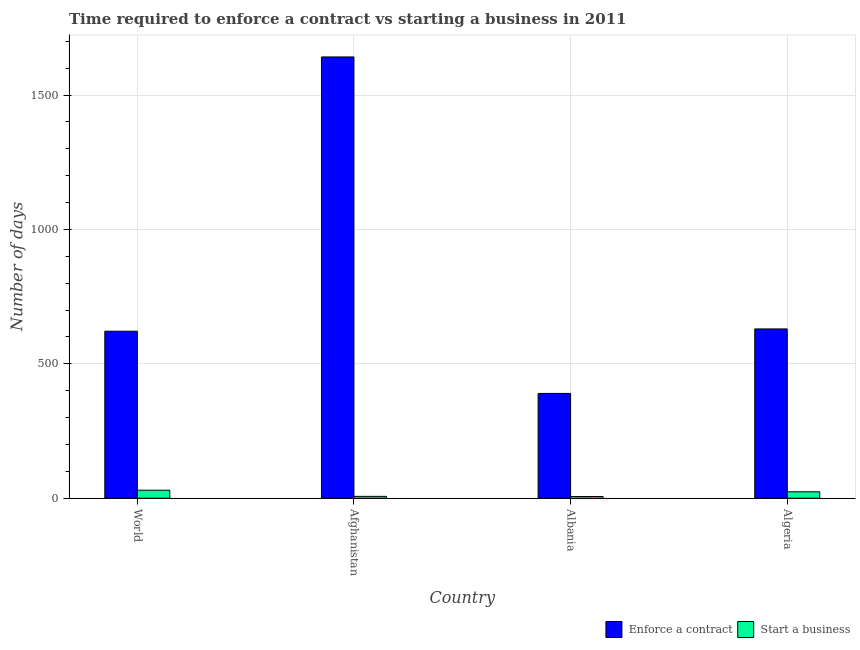How many different coloured bars are there?
Offer a very short reply. 2. How many groups of bars are there?
Your answer should be compact. 4. Are the number of bars per tick equal to the number of legend labels?
Provide a short and direct response. Yes. Are the number of bars on each tick of the X-axis equal?
Offer a very short reply. Yes. How many bars are there on the 2nd tick from the left?
Offer a terse response. 2. What is the label of the 4th group of bars from the left?
Your answer should be compact. Algeria. In how many cases, is the number of bars for a given country not equal to the number of legend labels?
Provide a succinct answer. 0. What is the number of days to enforece a contract in World?
Make the answer very short. 621.51. Across all countries, what is the maximum number of days to start a business?
Offer a terse response. 29.9. Across all countries, what is the minimum number of days to enforece a contract?
Ensure brevity in your answer.  390. In which country was the number of days to enforece a contract maximum?
Give a very brief answer. Afghanistan. In which country was the number of days to start a business minimum?
Provide a short and direct response. Albania. What is the total number of days to start a business in the graph?
Your response must be concise. 67.4. What is the difference between the number of days to enforece a contract in Albania and that in World?
Provide a succinct answer. -231.51. What is the difference between the number of days to enforece a contract in Algeria and the number of days to start a business in Albania?
Provide a succinct answer. 623.5. What is the average number of days to enforece a contract per country?
Your answer should be very brief. 820.88. What is the difference between the number of days to start a business and number of days to enforece a contract in Albania?
Ensure brevity in your answer.  -383.5. What is the ratio of the number of days to enforece a contract in Afghanistan to that in Albania?
Ensure brevity in your answer.  4.21. Is the number of days to enforece a contract in Afghanistan less than that in Algeria?
Provide a short and direct response. No. What is the difference between the highest and the second highest number of days to enforece a contract?
Ensure brevity in your answer.  1012. What is the difference between the highest and the lowest number of days to start a business?
Your answer should be very brief. 23.4. Is the sum of the number of days to enforece a contract in Algeria and World greater than the maximum number of days to start a business across all countries?
Your answer should be very brief. Yes. What does the 1st bar from the left in Algeria represents?
Provide a short and direct response. Enforce a contract. What does the 1st bar from the right in Afghanistan represents?
Offer a terse response. Start a business. Are all the bars in the graph horizontal?
Make the answer very short. No. Does the graph contain grids?
Ensure brevity in your answer.  Yes. Where does the legend appear in the graph?
Provide a short and direct response. Bottom right. How are the legend labels stacked?
Offer a terse response. Horizontal. What is the title of the graph?
Your answer should be compact. Time required to enforce a contract vs starting a business in 2011. What is the label or title of the Y-axis?
Keep it short and to the point. Number of days. What is the Number of days in Enforce a contract in World?
Provide a short and direct response. 621.51. What is the Number of days in Start a business in World?
Keep it short and to the point. 29.9. What is the Number of days in Enforce a contract in Afghanistan?
Your answer should be compact. 1642. What is the Number of days of Enforce a contract in Albania?
Ensure brevity in your answer.  390. What is the Number of days of Start a business in Albania?
Offer a very short reply. 6.5. What is the Number of days of Enforce a contract in Algeria?
Ensure brevity in your answer.  630. Across all countries, what is the maximum Number of days of Enforce a contract?
Offer a very short reply. 1642. Across all countries, what is the maximum Number of days of Start a business?
Give a very brief answer. 29.9. Across all countries, what is the minimum Number of days in Enforce a contract?
Offer a terse response. 390. Across all countries, what is the minimum Number of days in Start a business?
Ensure brevity in your answer.  6.5. What is the total Number of days of Enforce a contract in the graph?
Your answer should be very brief. 3283.51. What is the total Number of days in Start a business in the graph?
Your answer should be very brief. 67.4. What is the difference between the Number of days of Enforce a contract in World and that in Afghanistan?
Provide a short and direct response. -1020.49. What is the difference between the Number of days of Start a business in World and that in Afghanistan?
Your answer should be compact. 22.9. What is the difference between the Number of days in Enforce a contract in World and that in Albania?
Give a very brief answer. 231.51. What is the difference between the Number of days in Start a business in World and that in Albania?
Your answer should be very brief. 23.4. What is the difference between the Number of days in Enforce a contract in World and that in Algeria?
Your answer should be compact. -8.49. What is the difference between the Number of days in Start a business in World and that in Algeria?
Make the answer very short. 5.9. What is the difference between the Number of days in Enforce a contract in Afghanistan and that in Albania?
Provide a short and direct response. 1252. What is the difference between the Number of days in Start a business in Afghanistan and that in Albania?
Provide a short and direct response. 0.5. What is the difference between the Number of days in Enforce a contract in Afghanistan and that in Algeria?
Ensure brevity in your answer.  1012. What is the difference between the Number of days of Start a business in Afghanistan and that in Algeria?
Your response must be concise. -17. What is the difference between the Number of days of Enforce a contract in Albania and that in Algeria?
Keep it short and to the point. -240. What is the difference between the Number of days in Start a business in Albania and that in Algeria?
Your response must be concise. -17.5. What is the difference between the Number of days of Enforce a contract in World and the Number of days of Start a business in Afghanistan?
Your answer should be compact. 614.51. What is the difference between the Number of days of Enforce a contract in World and the Number of days of Start a business in Albania?
Make the answer very short. 615.01. What is the difference between the Number of days in Enforce a contract in World and the Number of days in Start a business in Algeria?
Offer a very short reply. 597.51. What is the difference between the Number of days of Enforce a contract in Afghanistan and the Number of days of Start a business in Albania?
Your response must be concise. 1635.5. What is the difference between the Number of days in Enforce a contract in Afghanistan and the Number of days in Start a business in Algeria?
Provide a short and direct response. 1618. What is the difference between the Number of days in Enforce a contract in Albania and the Number of days in Start a business in Algeria?
Make the answer very short. 366. What is the average Number of days in Enforce a contract per country?
Provide a short and direct response. 820.88. What is the average Number of days in Start a business per country?
Offer a terse response. 16.85. What is the difference between the Number of days in Enforce a contract and Number of days in Start a business in World?
Your response must be concise. 591.6. What is the difference between the Number of days of Enforce a contract and Number of days of Start a business in Afghanistan?
Your answer should be very brief. 1635. What is the difference between the Number of days of Enforce a contract and Number of days of Start a business in Albania?
Provide a short and direct response. 383.5. What is the difference between the Number of days in Enforce a contract and Number of days in Start a business in Algeria?
Keep it short and to the point. 606. What is the ratio of the Number of days in Enforce a contract in World to that in Afghanistan?
Your response must be concise. 0.38. What is the ratio of the Number of days of Start a business in World to that in Afghanistan?
Provide a succinct answer. 4.27. What is the ratio of the Number of days of Enforce a contract in World to that in Albania?
Offer a very short reply. 1.59. What is the ratio of the Number of days of Start a business in World to that in Albania?
Keep it short and to the point. 4.6. What is the ratio of the Number of days in Enforce a contract in World to that in Algeria?
Give a very brief answer. 0.99. What is the ratio of the Number of days of Start a business in World to that in Algeria?
Your answer should be very brief. 1.25. What is the ratio of the Number of days in Enforce a contract in Afghanistan to that in Albania?
Your answer should be very brief. 4.21. What is the ratio of the Number of days in Start a business in Afghanistan to that in Albania?
Your response must be concise. 1.08. What is the ratio of the Number of days in Enforce a contract in Afghanistan to that in Algeria?
Offer a terse response. 2.61. What is the ratio of the Number of days of Start a business in Afghanistan to that in Algeria?
Your response must be concise. 0.29. What is the ratio of the Number of days of Enforce a contract in Albania to that in Algeria?
Keep it short and to the point. 0.62. What is the ratio of the Number of days in Start a business in Albania to that in Algeria?
Provide a succinct answer. 0.27. What is the difference between the highest and the second highest Number of days in Enforce a contract?
Provide a succinct answer. 1012. What is the difference between the highest and the second highest Number of days in Start a business?
Provide a succinct answer. 5.9. What is the difference between the highest and the lowest Number of days in Enforce a contract?
Keep it short and to the point. 1252. What is the difference between the highest and the lowest Number of days of Start a business?
Ensure brevity in your answer.  23.4. 